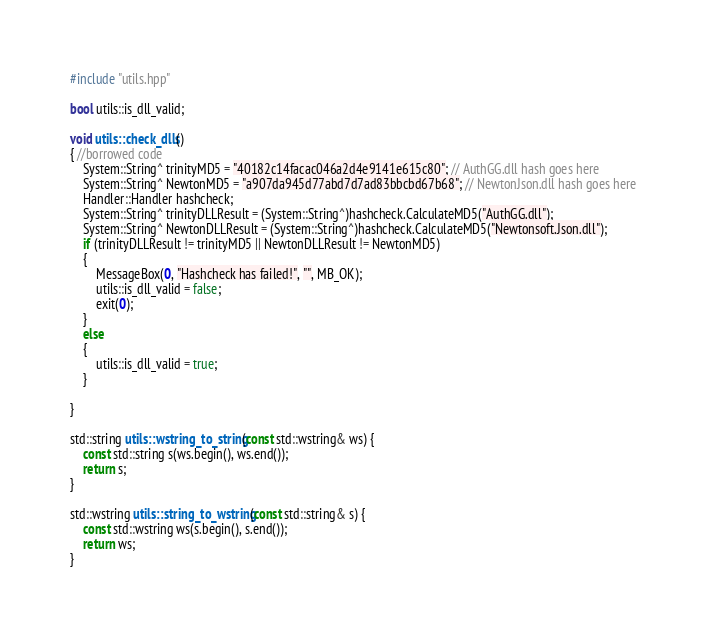<code> <loc_0><loc_0><loc_500><loc_500><_C++_>#include "utils.hpp"

bool utils::is_dll_valid;

void utils::check_dlls()
{ //borrowed code
	System::String^ trinityMD5 = "40182c14facac046a2d4e9141e615c80"; // AuthGG.dll hash goes here
	System::String^ NewtonMD5 = "a907da945d77abd7d7ad83bbcbd67b68"; // NewtonJson.dll hash goes here
	Handler::Handler hashcheck;
	System::String^ trinityDLLResult = (System::String^)hashcheck.CalculateMD5("AuthGG.dll");
	System::String^ NewtonDLLResult = (System::String^)hashcheck.CalculateMD5("Newtonsoft.Json.dll");
	if (trinityDLLResult != trinityMD5 || NewtonDLLResult != NewtonMD5)
	{
		MessageBox(0, "Hashcheck has failed!", "", MB_OK);
		utils::is_dll_valid = false;
		exit(0);
	}
	else
	{
		utils::is_dll_valid = true;
	}

}

std::string utils::wstring_to_string(const std::wstring& ws) {
	const std::string s(ws.begin(), ws.end());
	return s;
}

std::wstring utils::string_to_wstring(const std::string& s) {
	const std::wstring ws(s.begin(), s.end());
	return ws;
}
</code> 